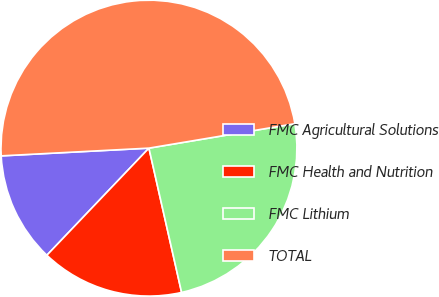Convert chart. <chart><loc_0><loc_0><loc_500><loc_500><pie_chart><fcel>FMC Agricultural Solutions<fcel>FMC Health and Nutrition<fcel>FMC Lithium<fcel>TOTAL<nl><fcel>12.05%<fcel>15.66%<fcel>24.1%<fcel>48.19%<nl></chart> 